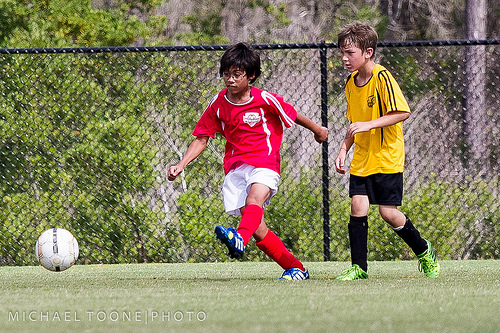<image>
Is there a boy to the left of the soccer ball? No. The boy is not to the left of the soccer ball. From this viewpoint, they have a different horizontal relationship. Where is the boy in relation to the fence? Is it behind the fence? No. The boy is not behind the fence. From this viewpoint, the boy appears to be positioned elsewhere in the scene. 